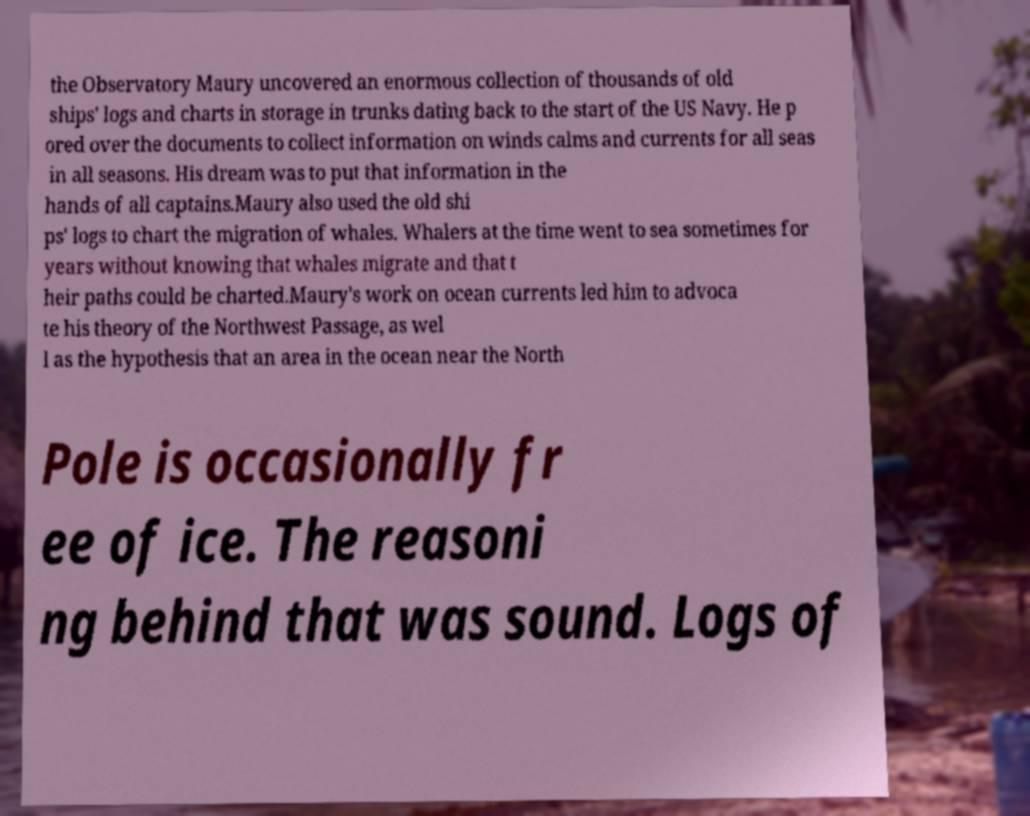For documentation purposes, I need the text within this image transcribed. Could you provide that? the Observatory Maury uncovered an enormous collection of thousands of old ships' logs and charts in storage in trunks dating back to the start of the US Navy. He p ored over the documents to collect information on winds calms and currents for all seas in all seasons. His dream was to put that information in the hands of all captains.Maury also used the old shi ps' logs to chart the migration of whales. Whalers at the time went to sea sometimes for years without knowing that whales migrate and that t heir paths could be charted.Maury's work on ocean currents led him to advoca te his theory of the Northwest Passage, as wel l as the hypothesis that an area in the ocean near the North Pole is occasionally fr ee of ice. The reasoni ng behind that was sound. Logs of 